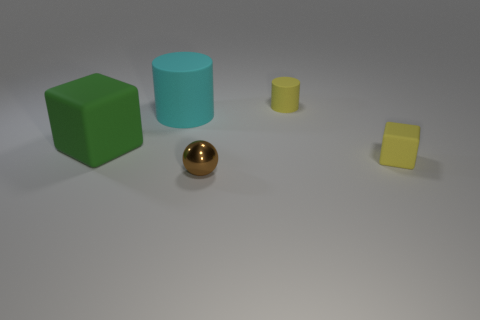How many other objects are the same color as the tiny cylinder?
Give a very brief answer. 1. There is a yellow rubber thing that is the same shape as the cyan object; what is its size?
Your answer should be compact. Small. What material is the object that is both in front of the large matte cube and behind the brown shiny ball?
Make the answer very short. Rubber. There is a rubber cylinder that is left of the brown ball; is its color the same as the small metal ball?
Make the answer very short. No. There is a large matte cylinder; is it the same color as the block behind the tiny yellow matte block?
Ensure brevity in your answer.  No. There is a big green cube; are there any matte cubes in front of it?
Provide a succinct answer. Yes. Does the tiny sphere have the same material as the green cube?
Offer a terse response. No. There is a brown object that is the same size as the yellow matte cylinder; what material is it?
Your response must be concise. Metal. How many things are either tiny objects on the right side of the metal object or large green matte things?
Provide a succinct answer. 3. Are there an equal number of small matte things right of the brown metallic ball and tiny yellow objects?
Make the answer very short. Yes. 